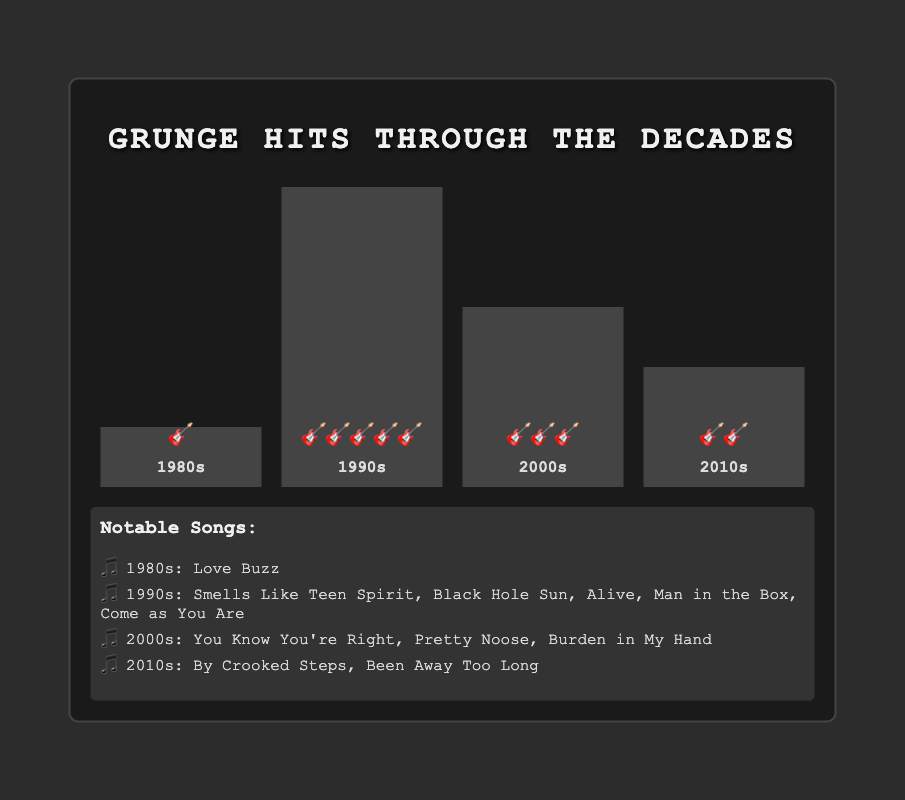What's the title of the chart? The title of the chart is displayed at the top in capital letters in bold font.
Answer: Grunge Hits Through the Decades Which decade has the most popular grunge songs based on the emojis? By counting the number of guitar emojis in each bar, we see that the 1990s have the most emojis, indicating the most popular grunge songs.
Answer: 1990s How many more popular grunge songs were there in the 1990s compared to the 2000s? The 1990s have 5 guitar emojis, while the 2000s have 3. Subtracting 3 from 5 gives us the difference.
Answer: 2 Which decade has the least number of popular grunge songs? By observing the bars, the 1980s have only one guitar emoji, indicating the least number of popular grunge songs.
Answer: 1980s What's the combined total of popular grunge songs from the 1980s and 2010s? The 1980s have 1 guitar emoji, and the 2010s have 2, adding them together gives us 1 + 2.
Answer: 3 Name one notable song from the 1980s. According to the list of notable songs below the chart, there is one song listed for the 1980s.
Answer: Love Buzz Which two decades have a combined total of 8 popular grunge songs? The 1990s have 5 emojis, and the 2000s have 3, adding these gives us 5 + 3, which equals 8.
Answer: 1990s and 2000s Compare the number of popular songs in the 2010s to the 2000s. Which has more? The 2000s have 3 guitar emojis, whereas the 2010s have 2 guitar emojis. Therefore, the 2000s have more popular grunge songs.
Answer: 2000s What visual element represents the number of popular grunge songs in each decade? Each guitar emoji (🎸) represents one popular grunge song for that decade.
Answer: Guitar emoji (🎸) What's the average number of popular grunge songs per decade? Adding the number of songs: 1 (1980s) + 5 (1990s) + 3 (2000s) + 2 (2010s) = 11. There are 4 decades, so divide by 4: 11 / 4 = 2.75.
Answer: 2.75 